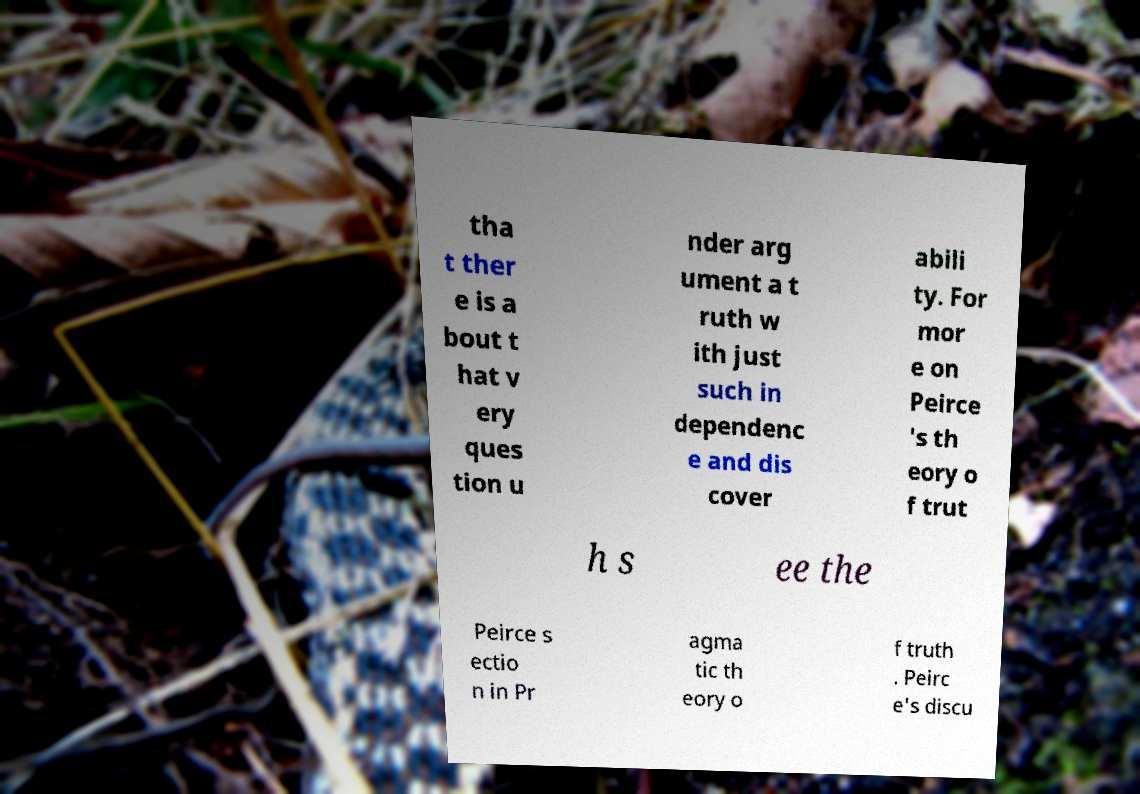Can you accurately transcribe the text from the provided image for me? tha t ther e is a bout t hat v ery ques tion u nder arg ument a t ruth w ith just such in dependenc e and dis cover abili ty. For mor e on Peirce 's th eory o f trut h s ee the Peirce s ectio n in Pr agma tic th eory o f truth . Peirc e's discu 